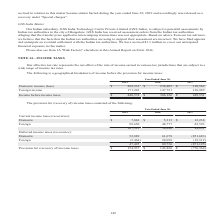According to Opentext Corporation's financial document, What does the table represent? geographical breakdown of income before the provision for income taxes. The document states: "The following is a geographical breakdown of income before the provision for income taxes:..." Also, What does the effective tax rate represent? net effect of the mix of income earned in various tax jurisdictions that are subject to a wide range of income tax rates. The document states: "Our effective tax rate represents the net effect of the mix of income earned in various tax jurisdictions that are subject to a wide range of income t..." Also, What are the fiscal years included in the table? The document contains multiple relevant values: 2019, 2018, 2017. From the document: "2019 2018 2017 Domestic income (loss) $ 269,331 $ 238,405 $ 110,562 Foreign income 171,243 147,721 138,989 Income 2019 2018 2017 Domestic income (loss..." Also, can you calculate: What is the average annual Income before income taxes? To answer this question, I need to perform calculations using the financial data. The calculation is: (440,574+386,126+249,551)/3, which equals 358750.33. This is based on the information: "21 138,989 Income before income taxes $ 440,574 $ 386,126 $ 249,551 Income before income taxes $ 440,574 $ 386,126 $ 249,551 ,243 147,721 138,989 Income before income taxes $ 440,574 $ 386,126 $ 249,5..." The key data points involved are: 249,551, 386,126, 440,574. Also, can you calculate: For Fiscal year 2019, what is the Foreign income expressed as a percentage of Income before income taxes? Based on the calculation: 171,243/440,574, the result is 38.87 (percentage). This is based on the information: "oss) $ 269,331 $ 238,405 $ 110,562 Foreign income 171,243 147,721 138,989 Income before income taxes $ 440,574 $ 386,126 $ 249,551 ,243 147,721 138,989 Income before income taxes $ 440,574 $ 386,126 $..." The key data points involved are: 171,243, 440,574. Additionally, In what years did Income before income taxes exceed $300,000? The document shows two values: 2019 and 2018. From the document: "2019 2018 2017 Domestic income (loss) $ 269,331 $ 238,405 $ 110,562 Foreign income 171,243 147,721 138,9 2019 2018 2017 Domestic income (loss) $ 269,3..." 